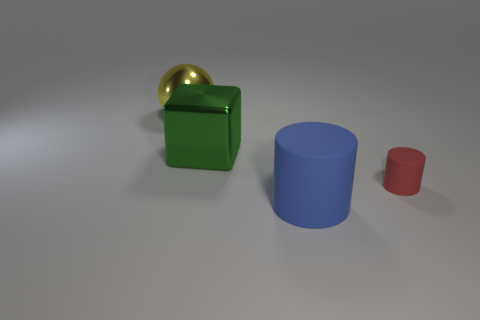Is the number of large things that are in front of the big green metal object greater than the number of rubber things that are behind the big sphere?
Offer a terse response. Yes. What material is the object that is right of the big thing that is in front of the large green metallic block that is on the left side of the tiny matte cylinder?
Your response must be concise. Rubber. What shape is the yellow thing that is made of the same material as the green block?
Provide a succinct answer. Sphere. Is there a block behind the metal object to the right of the ball?
Your answer should be compact. No. The red rubber object has what size?
Provide a succinct answer. Small. What number of things are either gray cylinders or cylinders?
Provide a short and direct response. 2. Is the big object in front of the tiny cylinder made of the same material as the large object that is behind the big block?
Ensure brevity in your answer.  No. There is a large object that is the same material as the cube; what is its color?
Make the answer very short. Yellow. How many shiny objects are the same size as the block?
Provide a short and direct response. 1. What number of other objects are there of the same color as the big rubber object?
Provide a short and direct response. 0. 